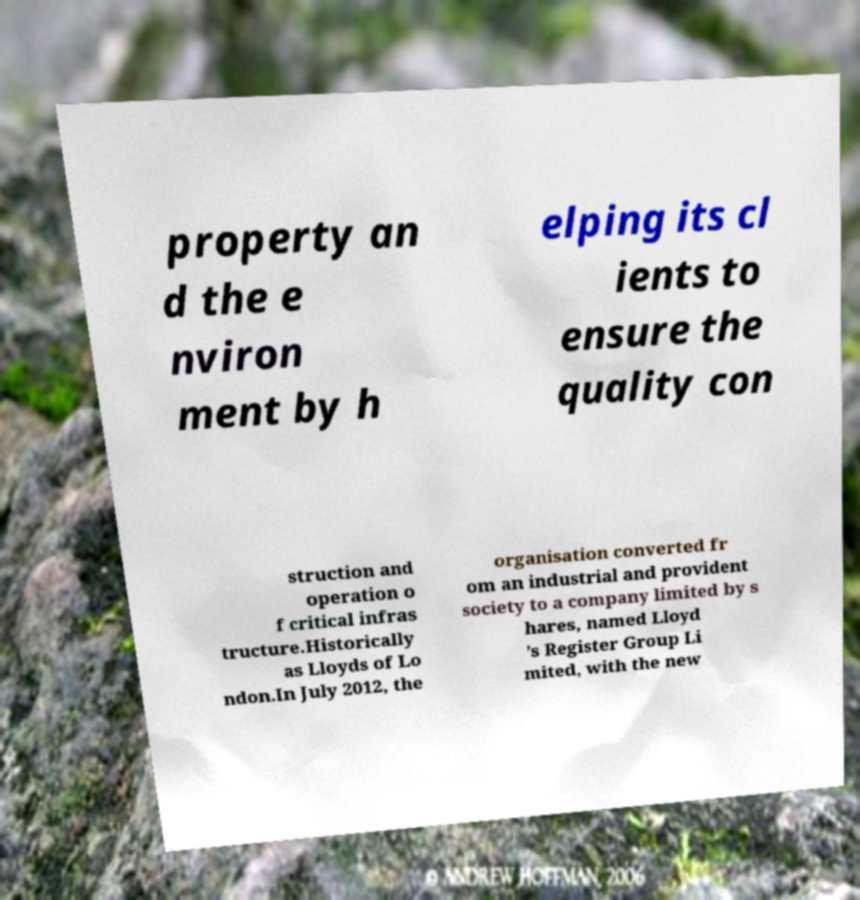Could you assist in decoding the text presented in this image and type it out clearly? property an d the e nviron ment by h elping its cl ients to ensure the quality con struction and operation o f critical infras tructure.Historically as Lloyds of Lo ndon.In July 2012, the organisation converted fr om an industrial and provident society to a company limited by s hares, named Lloyd ’s Register Group Li mited, with the new 